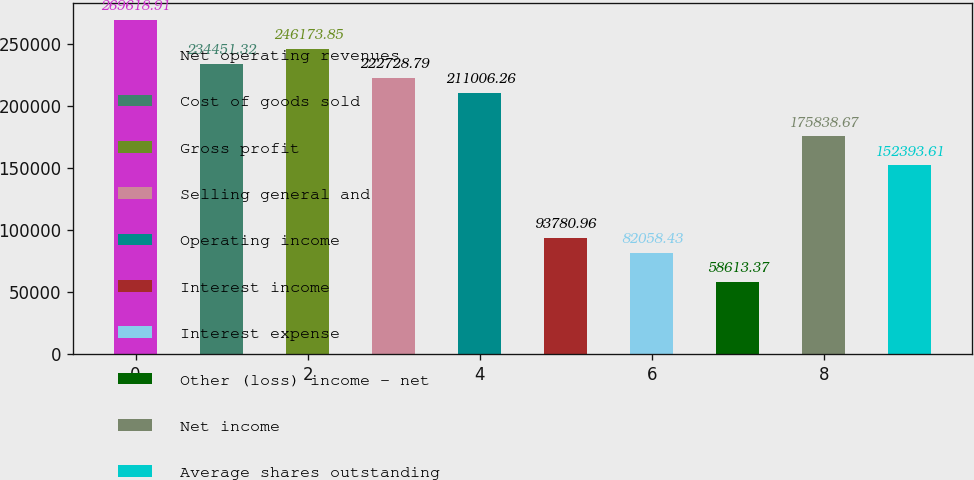<chart> <loc_0><loc_0><loc_500><loc_500><bar_chart><fcel>Net operating revenues<fcel>Cost of goods sold<fcel>Gross profit<fcel>Selling general and<fcel>Operating income<fcel>Interest income<fcel>Interest expense<fcel>Other (loss) income - net<fcel>Net income<fcel>Average shares outstanding<nl><fcel>269619<fcel>234451<fcel>246174<fcel>222729<fcel>211006<fcel>93781<fcel>82058.4<fcel>58613.4<fcel>175839<fcel>152394<nl></chart> 